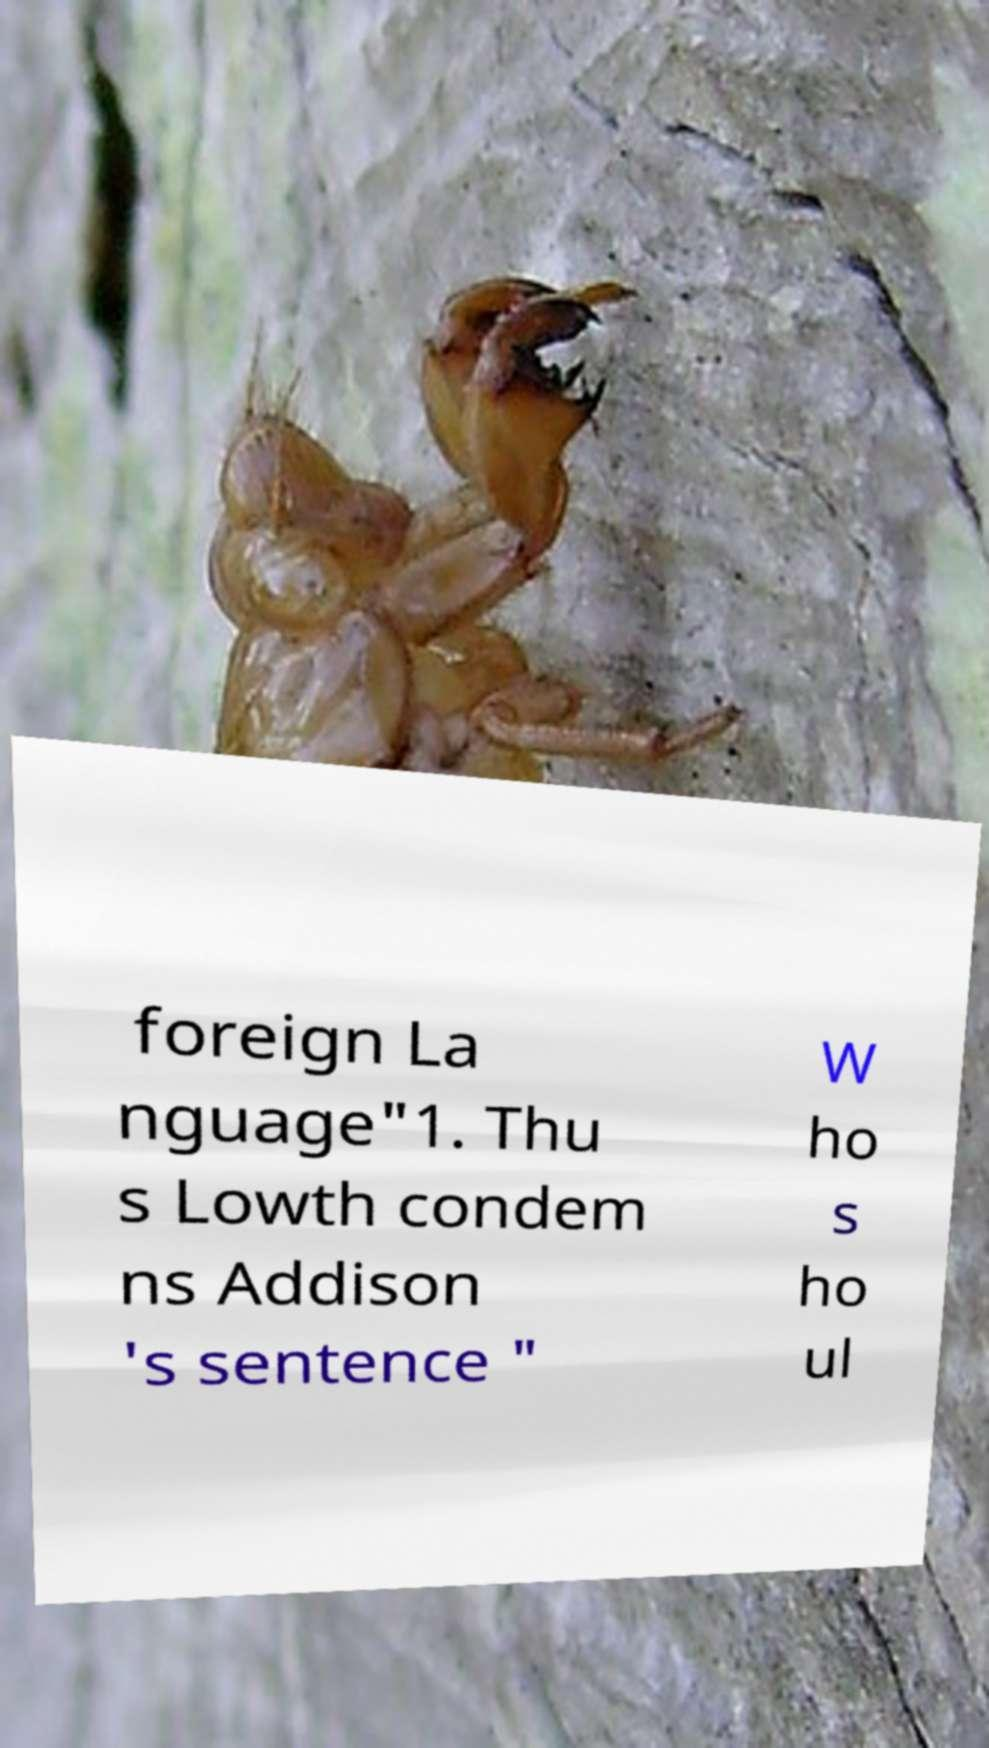Please identify and transcribe the text found in this image. foreign La nguage"1. Thu s Lowth condem ns Addison 's sentence " W ho s ho ul 